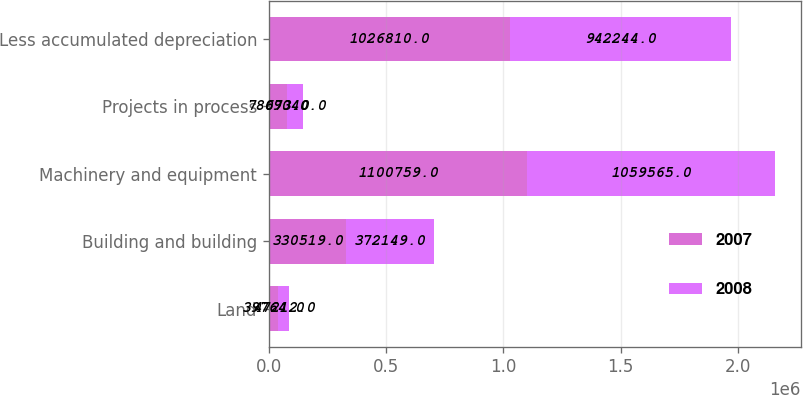Convert chart. <chart><loc_0><loc_0><loc_500><loc_500><stacked_bar_chart><ecel><fcel>Land<fcel>Building and building<fcel>Machinery and equipment<fcel>Projects in process<fcel>Less accumulated depreciation<nl><fcel>2007<fcel>39764<fcel>330519<fcel>1.10076e+06<fcel>78073<fcel>1.02681e+06<nl><fcel>2008<fcel>47212<fcel>372149<fcel>1.05956e+06<fcel>69040<fcel>942244<nl></chart> 